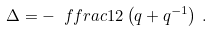Convert formula to latex. <formula><loc_0><loc_0><loc_500><loc_500>\Delta = - \ f f r a c 1 2 \left ( q + q ^ { - 1 } \right ) \, .</formula> 